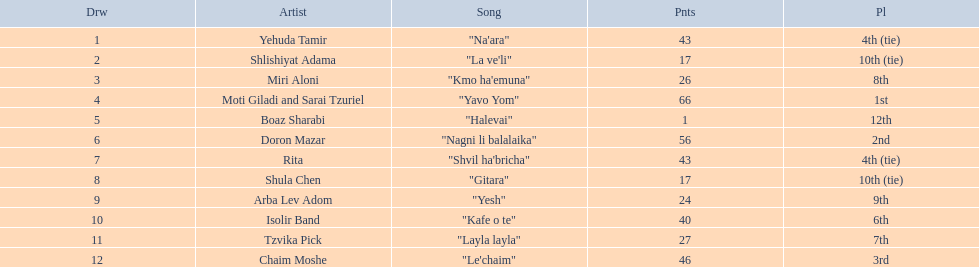What are the points? 43, 17, 26, 66, 1, 56, 43, 17, 24, 40, 27, 46. What is the least? 1. Which artist has that much Boaz Sharabi. 